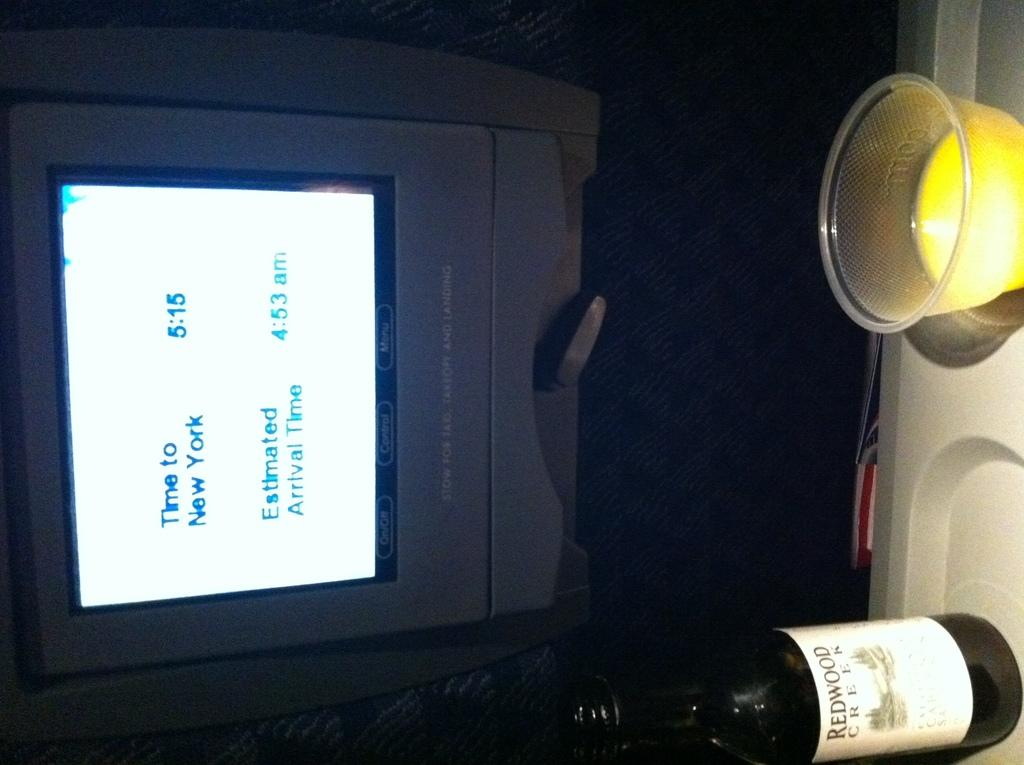<image>
Write a terse but informative summary of the picture. Screen which shows the time to New York at 5:15. 